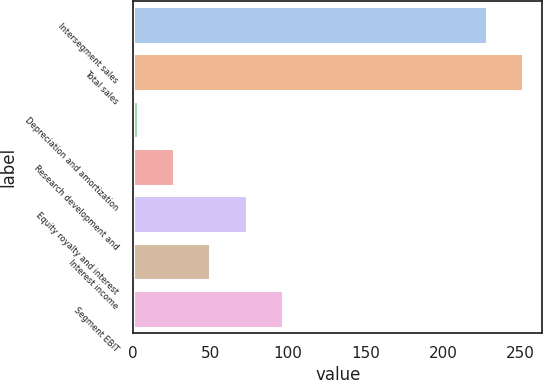Convert chart. <chart><loc_0><loc_0><loc_500><loc_500><bar_chart><fcel>Intersegment sales<fcel>Total sales<fcel>Depreciation and amortization<fcel>Research development and<fcel>Equity royalty and interest<fcel>Interest income<fcel>Segment EBIT<nl><fcel>228<fcel>251.4<fcel>3<fcel>26.4<fcel>73.2<fcel>49.8<fcel>96.6<nl></chart> 